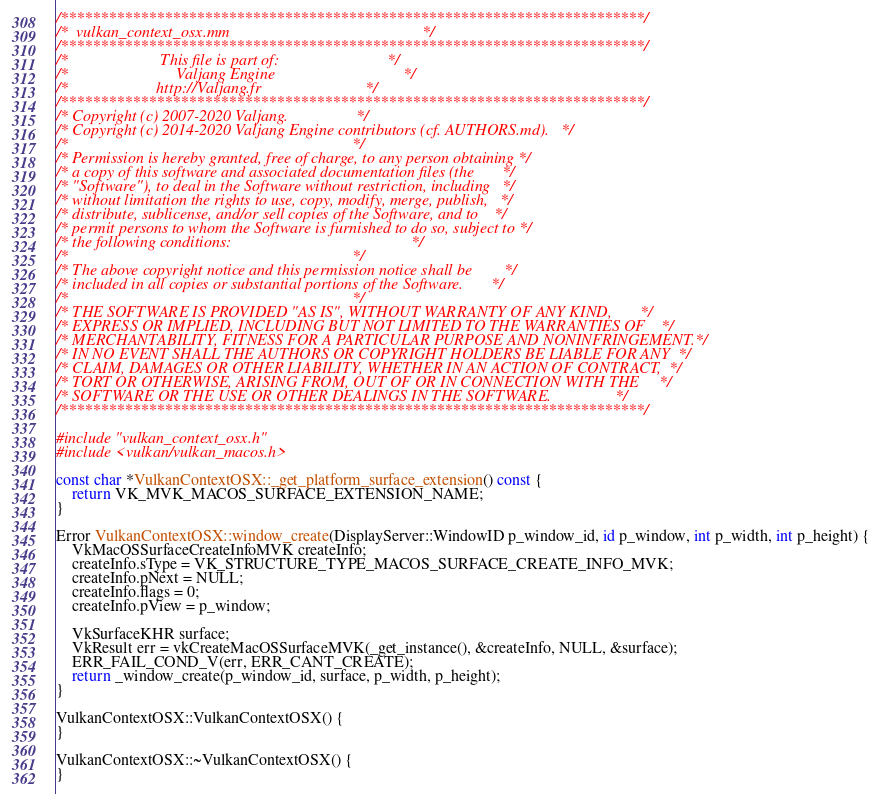Convert code to text. <code><loc_0><loc_0><loc_500><loc_500><_ObjectiveC_>/*************************************************************************/
/*  vulkan_context_osx.mm                                                */
/*************************************************************************/
/*                       This file is part of:                           */
/*                           Valjang Engine                                */
/*                      http://Valjang.fr                          */
/*************************************************************************/
/* Copyright (c) 2007-2020 Valjang.                 */
/* Copyright (c) 2014-2020 Valjang Engine contributors (cf. AUTHORS.md).   */
/*                                                                       */
/* Permission is hereby granted, free of charge, to any person obtaining */
/* a copy of this software and associated documentation files (the       */
/* "Software"), to deal in the Software without restriction, including   */
/* without limitation the rights to use, copy, modify, merge, publish,   */
/* distribute, sublicense, and/or sell copies of the Software, and to    */
/* permit persons to whom the Software is furnished to do so, subject to */
/* the following conditions:                                             */
/*                                                                       */
/* The above copyright notice and this permission notice shall be        */
/* included in all copies or substantial portions of the Software.       */
/*                                                                       */
/* THE SOFTWARE IS PROVIDED "AS IS", WITHOUT WARRANTY OF ANY KIND,       */
/* EXPRESS OR IMPLIED, INCLUDING BUT NOT LIMITED TO THE WARRANTIES OF    */
/* MERCHANTABILITY, FITNESS FOR A PARTICULAR PURPOSE AND NONINFRINGEMENT.*/
/* IN NO EVENT SHALL THE AUTHORS OR COPYRIGHT HOLDERS BE LIABLE FOR ANY  */
/* CLAIM, DAMAGES OR OTHER LIABILITY, WHETHER IN AN ACTION OF CONTRACT,  */
/* TORT OR OTHERWISE, ARISING FROM, OUT OF OR IN CONNECTION WITH THE     */
/* SOFTWARE OR THE USE OR OTHER DEALINGS IN THE SOFTWARE.                */
/*************************************************************************/

#include "vulkan_context_osx.h"
#include <vulkan/vulkan_macos.h>

const char *VulkanContextOSX::_get_platform_surface_extension() const {
	return VK_MVK_MACOS_SURFACE_EXTENSION_NAME;
}

Error VulkanContextOSX::window_create(DisplayServer::WindowID p_window_id, id p_window, int p_width, int p_height) {
	VkMacOSSurfaceCreateInfoMVK createInfo;
	createInfo.sType = VK_STRUCTURE_TYPE_MACOS_SURFACE_CREATE_INFO_MVK;
	createInfo.pNext = NULL;
	createInfo.flags = 0;
	createInfo.pView = p_window;

	VkSurfaceKHR surface;
	VkResult err = vkCreateMacOSSurfaceMVK(_get_instance(), &createInfo, NULL, &surface);
	ERR_FAIL_COND_V(err, ERR_CANT_CREATE);
	return _window_create(p_window_id, surface, p_width, p_height);
}

VulkanContextOSX::VulkanContextOSX() {
}

VulkanContextOSX::~VulkanContextOSX() {
}
</code> 